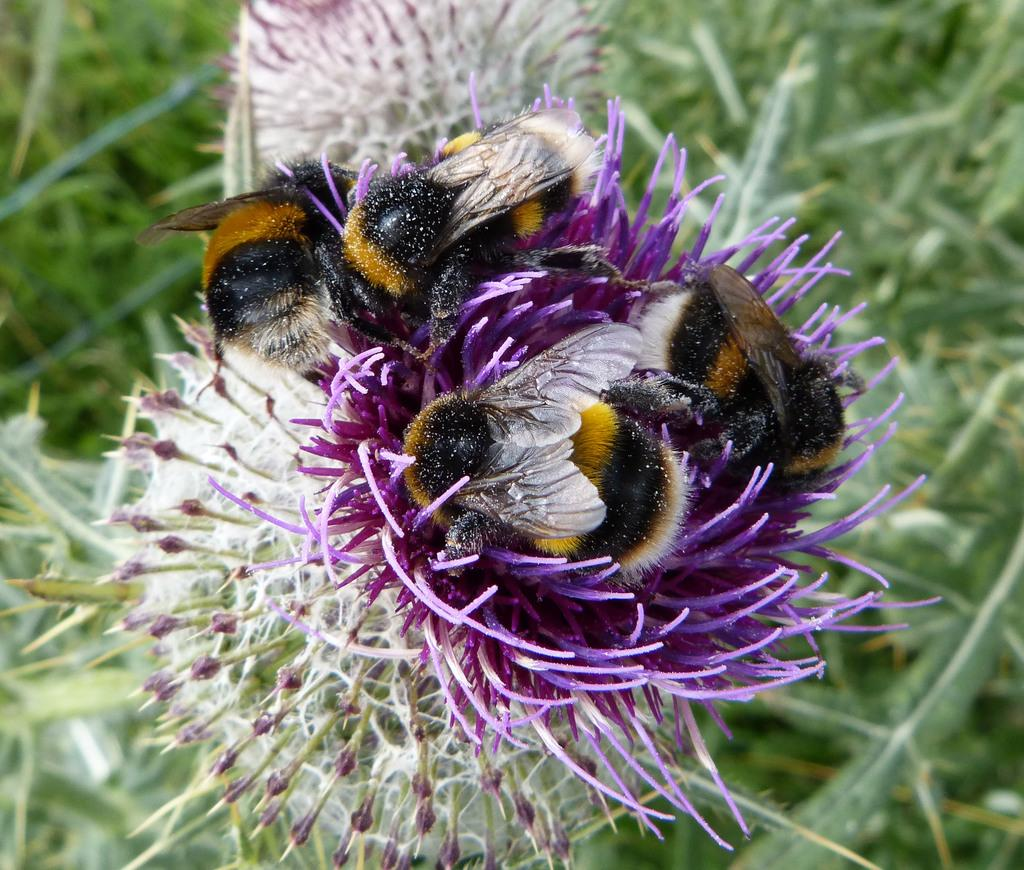What type of plants can be seen in the image? There are flowers in the image. How many honey bees are on a flower in the image? There are four honey bees on a flower in the image. What type of vegetation is present around the flowers in the image? There is grass around the flowers in the image. What type of advertisement is being displayed on the flower in the image? There is no advertisement present in the image. The image features flowers and honey bees. 